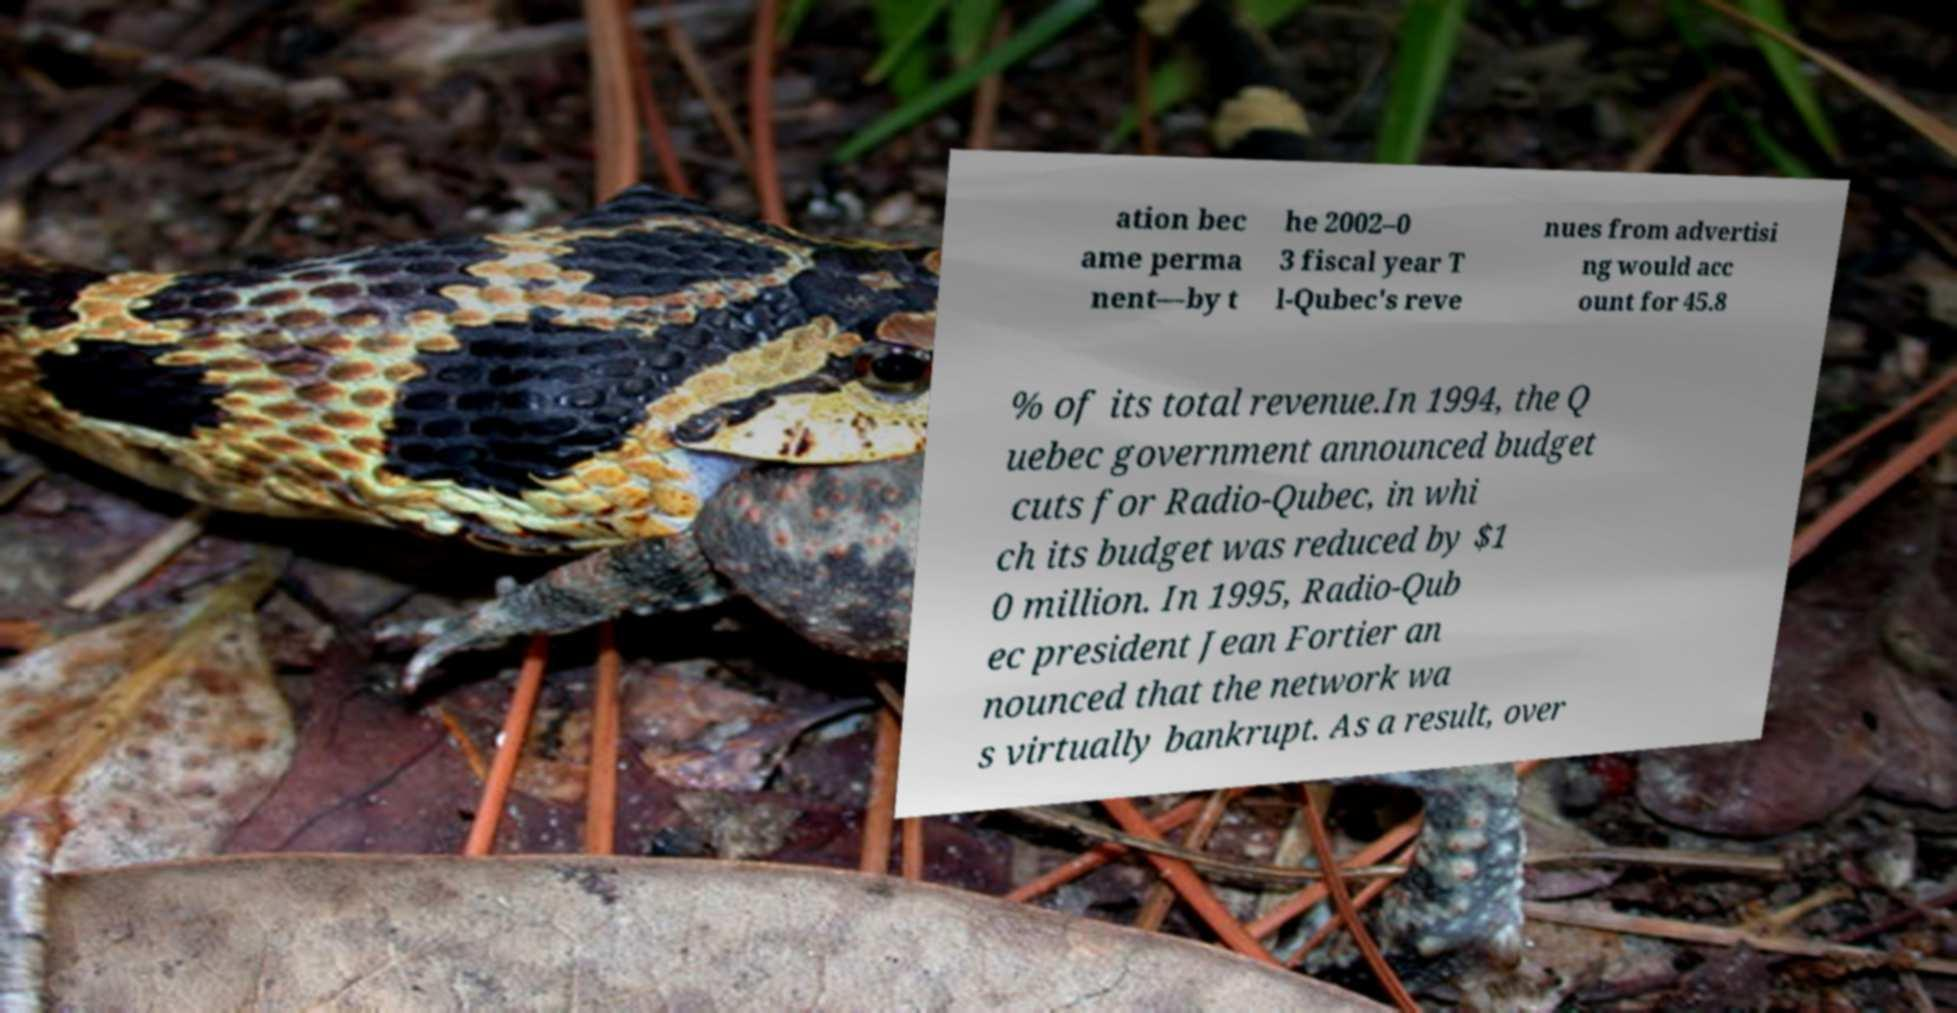Please read and relay the text visible in this image. What does it say? ation bec ame perma nent—by t he 2002–0 3 fiscal year T l-Qubec's reve nues from advertisi ng would acc ount for 45.8 % of its total revenue.In 1994, the Q uebec government announced budget cuts for Radio-Qubec, in whi ch its budget was reduced by $1 0 million. In 1995, Radio-Qub ec president Jean Fortier an nounced that the network wa s virtually bankrupt. As a result, over 